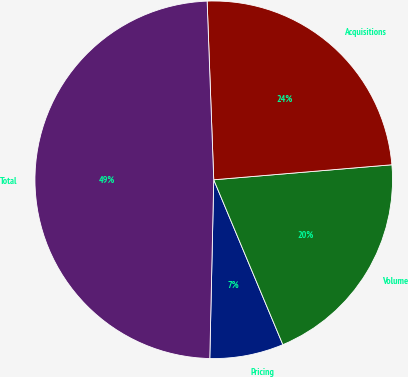Convert chart to OTSL. <chart><loc_0><loc_0><loc_500><loc_500><pie_chart><fcel>Pricing<fcel>Volume<fcel>Acquisitions<fcel>Total<nl><fcel>6.67%<fcel>20.02%<fcel>24.25%<fcel>49.06%<nl></chart> 